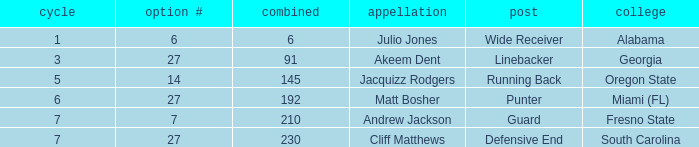Which overall's pick number was 14? 145.0. 